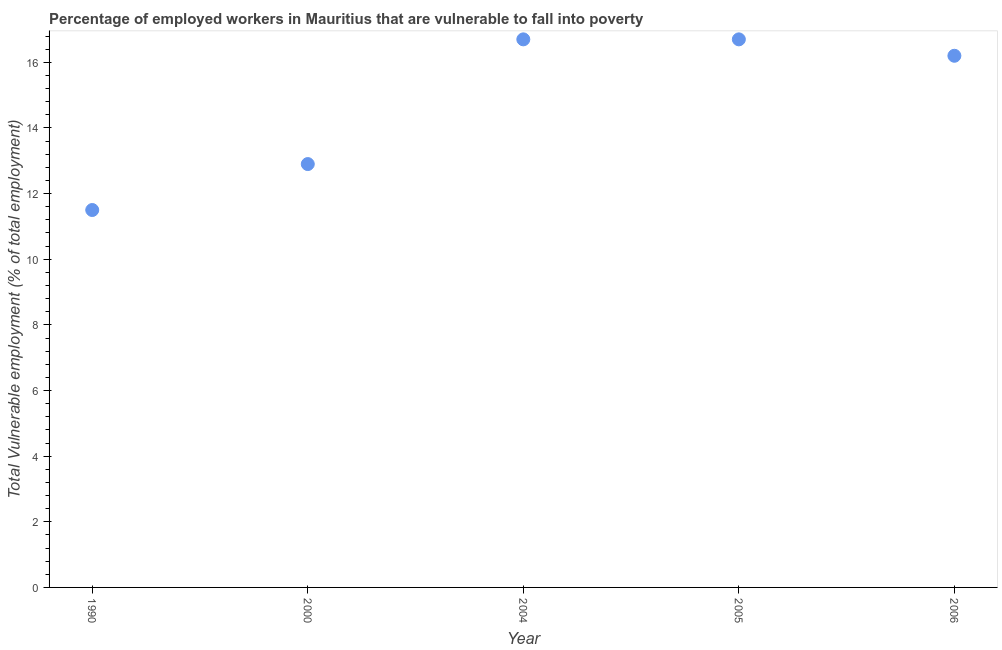What is the total vulnerable employment in 2005?
Your answer should be very brief. 16.7. Across all years, what is the maximum total vulnerable employment?
Offer a terse response. 16.7. In which year was the total vulnerable employment minimum?
Provide a succinct answer. 1990. What is the sum of the total vulnerable employment?
Your answer should be compact. 74. What is the difference between the total vulnerable employment in 2004 and 2005?
Make the answer very short. 0. What is the average total vulnerable employment per year?
Your answer should be very brief. 14.8. What is the median total vulnerable employment?
Your answer should be compact. 16.2. In how many years, is the total vulnerable employment greater than 6.4 %?
Keep it short and to the point. 5. What is the ratio of the total vulnerable employment in 1990 to that in 2000?
Your answer should be very brief. 0.89. Is the total vulnerable employment in 2004 less than that in 2005?
Make the answer very short. No. Is the difference between the total vulnerable employment in 1990 and 2006 greater than the difference between any two years?
Your answer should be compact. No. Is the sum of the total vulnerable employment in 1990 and 2000 greater than the maximum total vulnerable employment across all years?
Your answer should be compact. Yes. What is the difference between the highest and the lowest total vulnerable employment?
Give a very brief answer. 5.2. In how many years, is the total vulnerable employment greater than the average total vulnerable employment taken over all years?
Your answer should be very brief. 3. How many dotlines are there?
Offer a terse response. 1. Are the values on the major ticks of Y-axis written in scientific E-notation?
Ensure brevity in your answer.  No. What is the title of the graph?
Keep it short and to the point. Percentage of employed workers in Mauritius that are vulnerable to fall into poverty. What is the label or title of the X-axis?
Ensure brevity in your answer.  Year. What is the label or title of the Y-axis?
Give a very brief answer. Total Vulnerable employment (% of total employment). What is the Total Vulnerable employment (% of total employment) in 1990?
Ensure brevity in your answer.  11.5. What is the Total Vulnerable employment (% of total employment) in 2000?
Offer a terse response. 12.9. What is the Total Vulnerable employment (% of total employment) in 2004?
Provide a succinct answer. 16.7. What is the Total Vulnerable employment (% of total employment) in 2005?
Keep it short and to the point. 16.7. What is the Total Vulnerable employment (% of total employment) in 2006?
Your response must be concise. 16.2. What is the difference between the Total Vulnerable employment (% of total employment) in 1990 and 2000?
Offer a terse response. -1.4. What is the difference between the Total Vulnerable employment (% of total employment) in 1990 and 2005?
Your answer should be very brief. -5.2. What is the difference between the Total Vulnerable employment (% of total employment) in 1990 and 2006?
Provide a short and direct response. -4.7. What is the difference between the Total Vulnerable employment (% of total employment) in 2000 and 2004?
Offer a very short reply. -3.8. What is the difference between the Total Vulnerable employment (% of total employment) in 2004 and 2005?
Provide a succinct answer. 0. What is the difference between the Total Vulnerable employment (% of total employment) in 2004 and 2006?
Offer a very short reply. 0.5. What is the ratio of the Total Vulnerable employment (% of total employment) in 1990 to that in 2000?
Keep it short and to the point. 0.89. What is the ratio of the Total Vulnerable employment (% of total employment) in 1990 to that in 2004?
Your response must be concise. 0.69. What is the ratio of the Total Vulnerable employment (% of total employment) in 1990 to that in 2005?
Your answer should be very brief. 0.69. What is the ratio of the Total Vulnerable employment (% of total employment) in 1990 to that in 2006?
Provide a short and direct response. 0.71. What is the ratio of the Total Vulnerable employment (% of total employment) in 2000 to that in 2004?
Keep it short and to the point. 0.77. What is the ratio of the Total Vulnerable employment (% of total employment) in 2000 to that in 2005?
Offer a very short reply. 0.77. What is the ratio of the Total Vulnerable employment (% of total employment) in 2000 to that in 2006?
Your answer should be very brief. 0.8. What is the ratio of the Total Vulnerable employment (% of total employment) in 2004 to that in 2006?
Make the answer very short. 1.03. What is the ratio of the Total Vulnerable employment (% of total employment) in 2005 to that in 2006?
Keep it short and to the point. 1.03. 